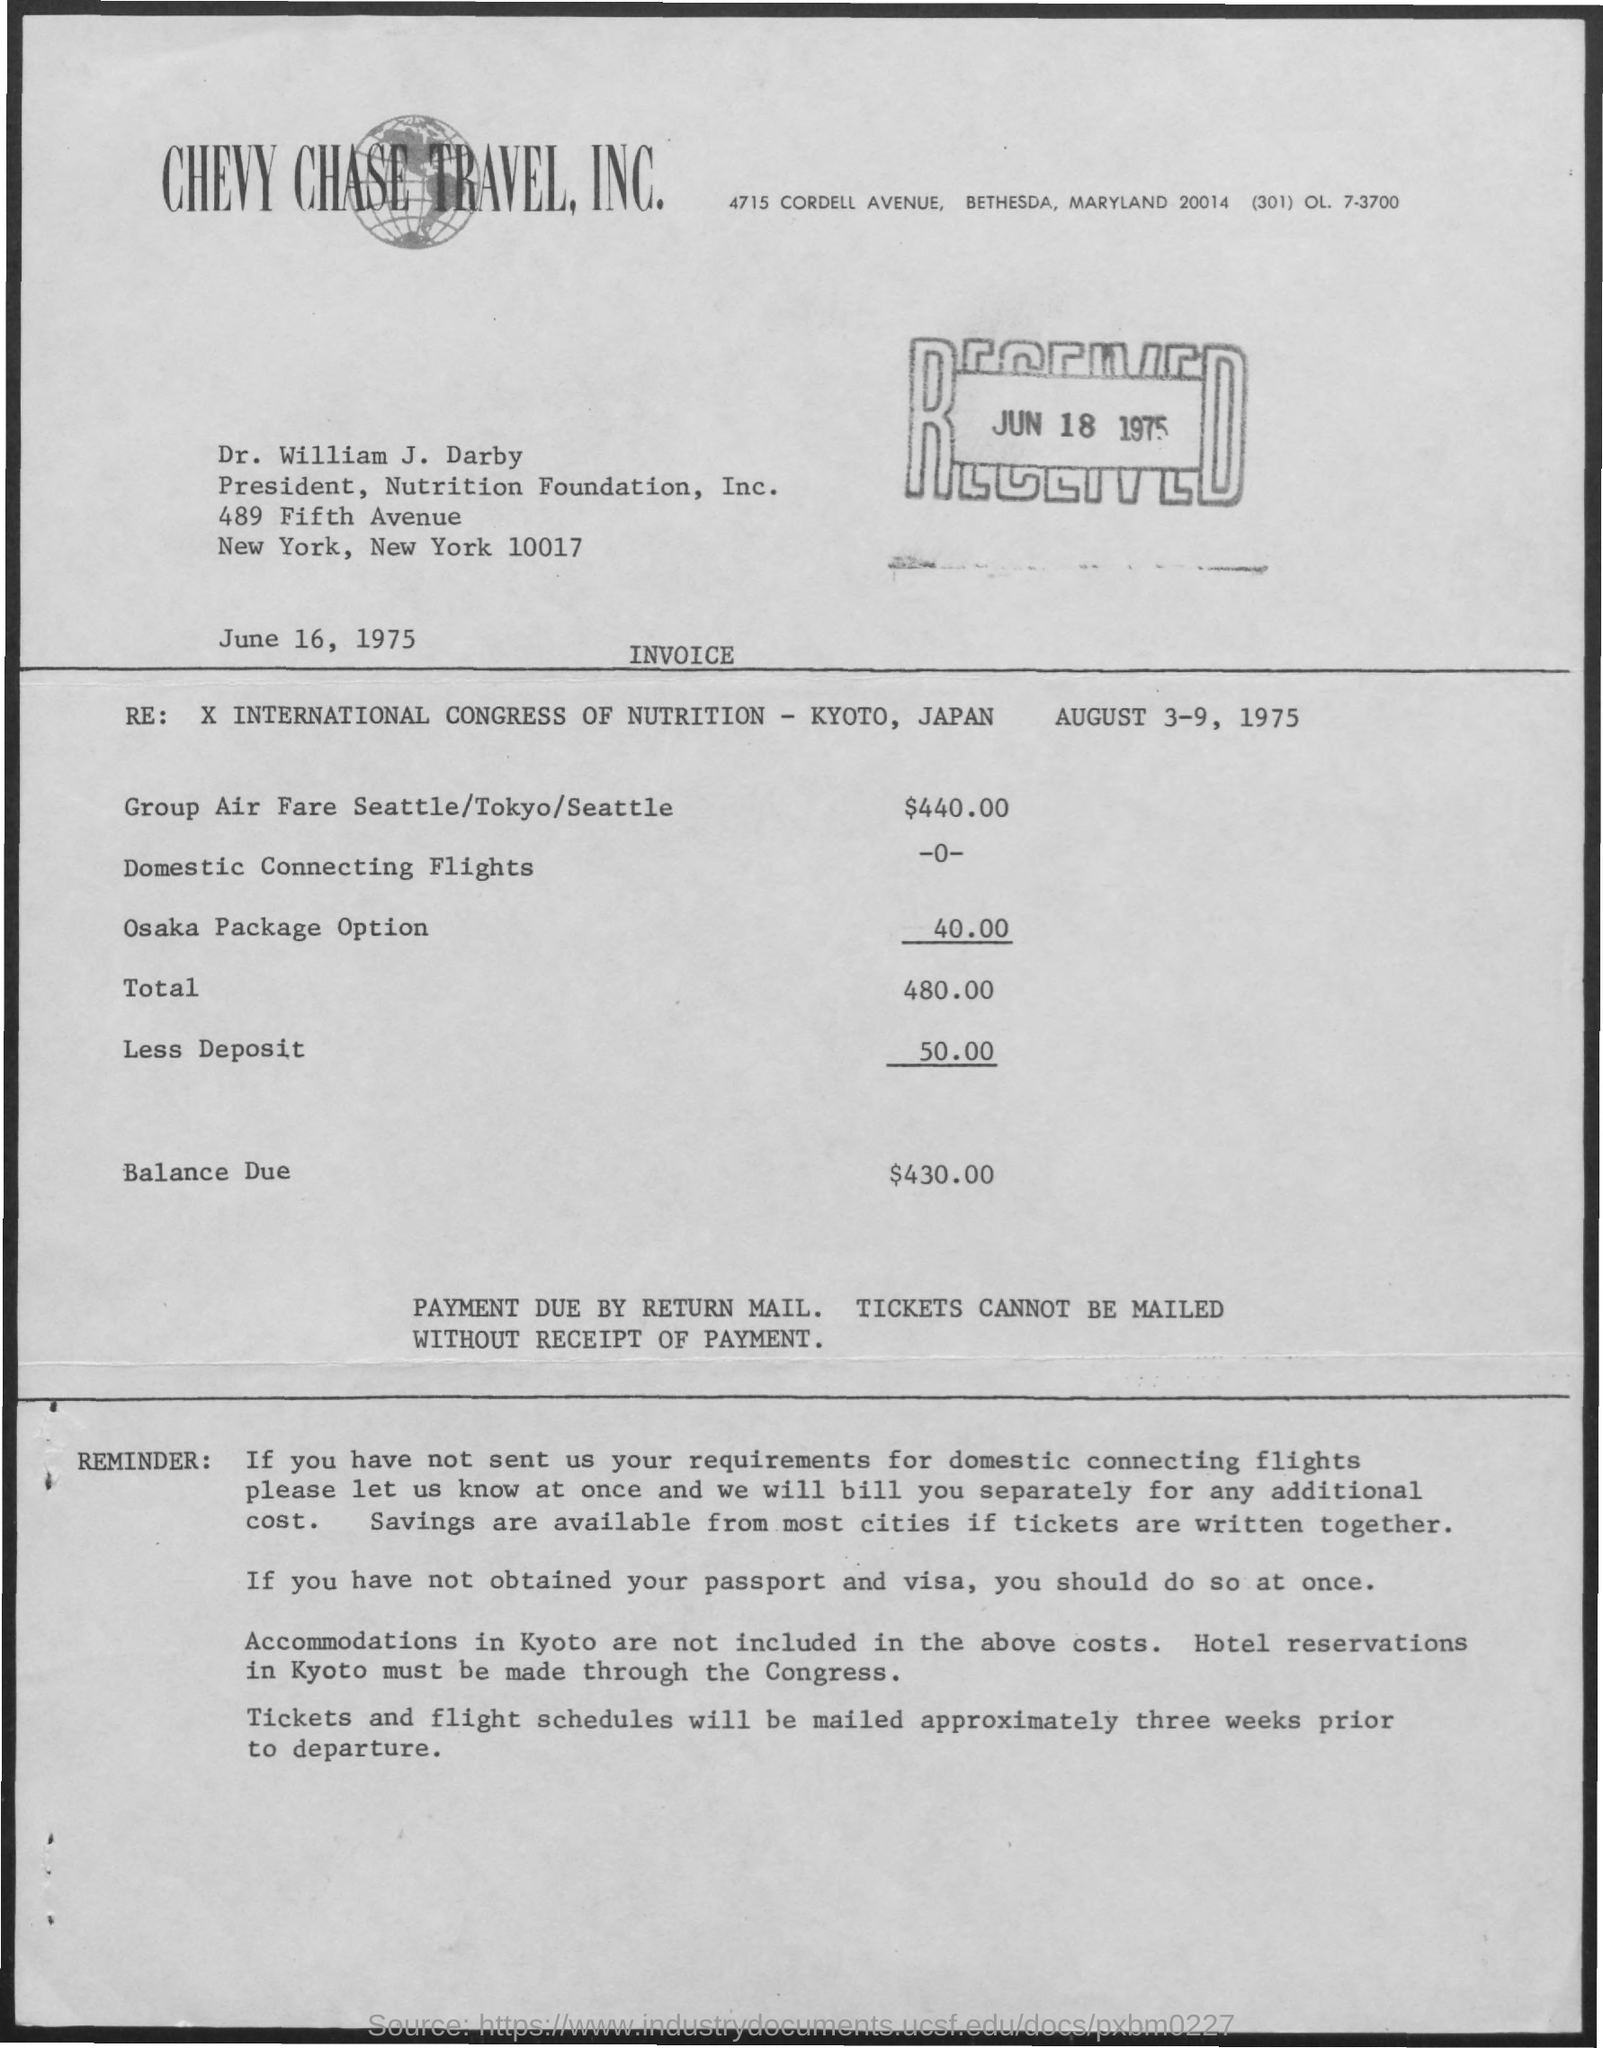Draw attention to some important aspects in this diagram. The cost of domestic connecting flights is currently unknown. The President of Nutrition Foundation, Inc. is Dr. William J. Darby. The received date of this invoice is June 18, 1975. 